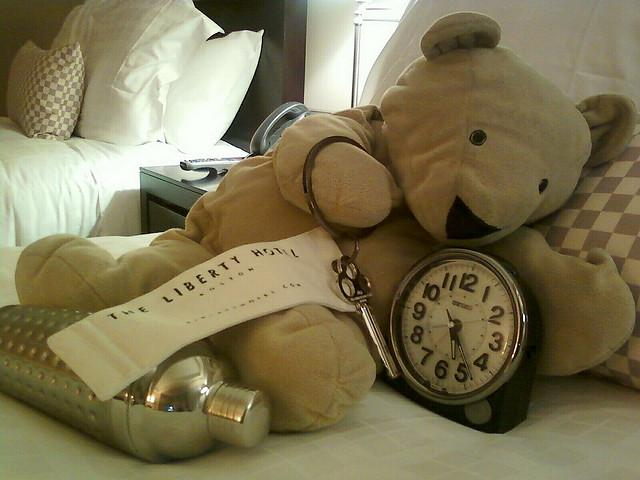What is hanging from the bear's wrist? key 